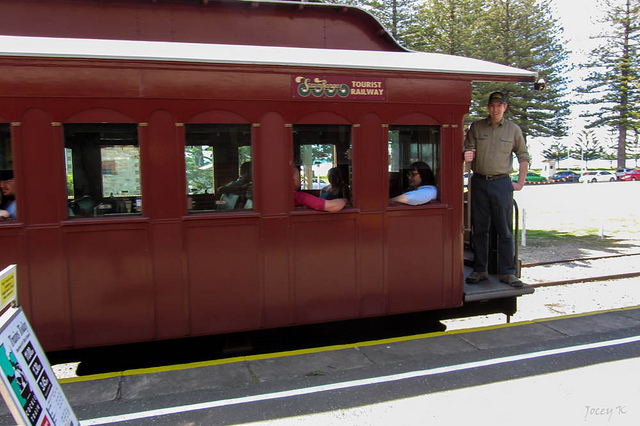What might be the backstory of this tourist railway car? This tourist railway car is a relic from a bygone era, lovingly restored to its former glory. Originally built in the early 20th century, it served as a main mode of transport, connecting small towns with the larger cities. Over the decades, as modern transportation evolved, the railway car fell into disuse. It was only through the efforts of dedicated train enthusiasts and historians that it was saved from being scrapped. Today, it stands as a moving museum, offering people a glimpse into the past, showcasing the craftsmanship and the stories of those who once traveled in its compartments. What kind of conversations do you think the passengers inside the railway car are having? The passengers inside the railway car are likely engaged in a variety of conversations. Some might be sharing stories about their previous travels and experiences, marveling at the vintage charm of the railway car. Others could be discussing the beautiful scenery outside, pointing out sights of interest as they glide past. There might also be families talking about their plans for the day, excited about the destinations they'll visit next and the activities they'll enjoy. Occasional laughter and expressions of awe fill the air, adding to the lively yet relaxed atmosphere inside the car. Imagine there's a hidden compartment in the railway car. What surprises could be found inside? If there were a hidden compartment in the railway car, it could hold a treasure trove of fascinating surprises. One might discover a collection of old letters and postcards, offering a glimpse into the personal stories and heartfelt messages of passengers from the past. Antique trinkets and souvenirs, like a pocket watch, a locket, or a map, could reveal the adventures and journeys undertaken. There might even be a diary belonging to a conductor or a frequent traveler, filled with sketches and observations from their travels. This secret stash would be a captivating time capsule, connecting the present passengers with the lives and memories of those who once rode the rails. 